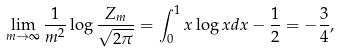Convert formula to latex. <formula><loc_0><loc_0><loc_500><loc_500>\lim _ { m \to \infty } \frac { 1 } { m ^ { 2 } } \log \frac { Z _ { m } } { \sqrt { 2 \pi } } = \int _ { 0 } ^ { 1 } x \log x d x - \frac { 1 } { 2 } = - \frac { 3 } { 4 } ,</formula> 